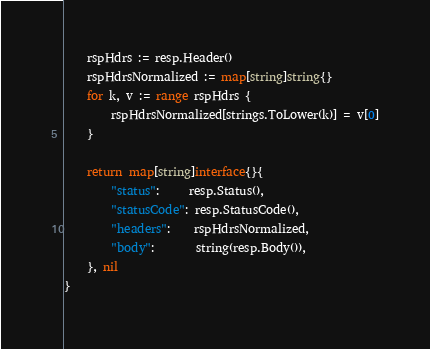<code> <loc_0><loc_0><loc_500><loc_500><_Go_>	rspHdrs := resp.Header()
	rspHdrsNormalized := map[string]string{}
	for k, v := range rspHdrs {
		rspHdrsNormalized[strings.ToLower(k)] = v[0]
	}

	return map[string]interface{}{
		"status":     resp.Status(),
		"statusCode": resp.StatusCode(),
		"headers":    rspHdrsNormalized,
		"body":       string(resp.Body()),
	}, nil
}
</code> 